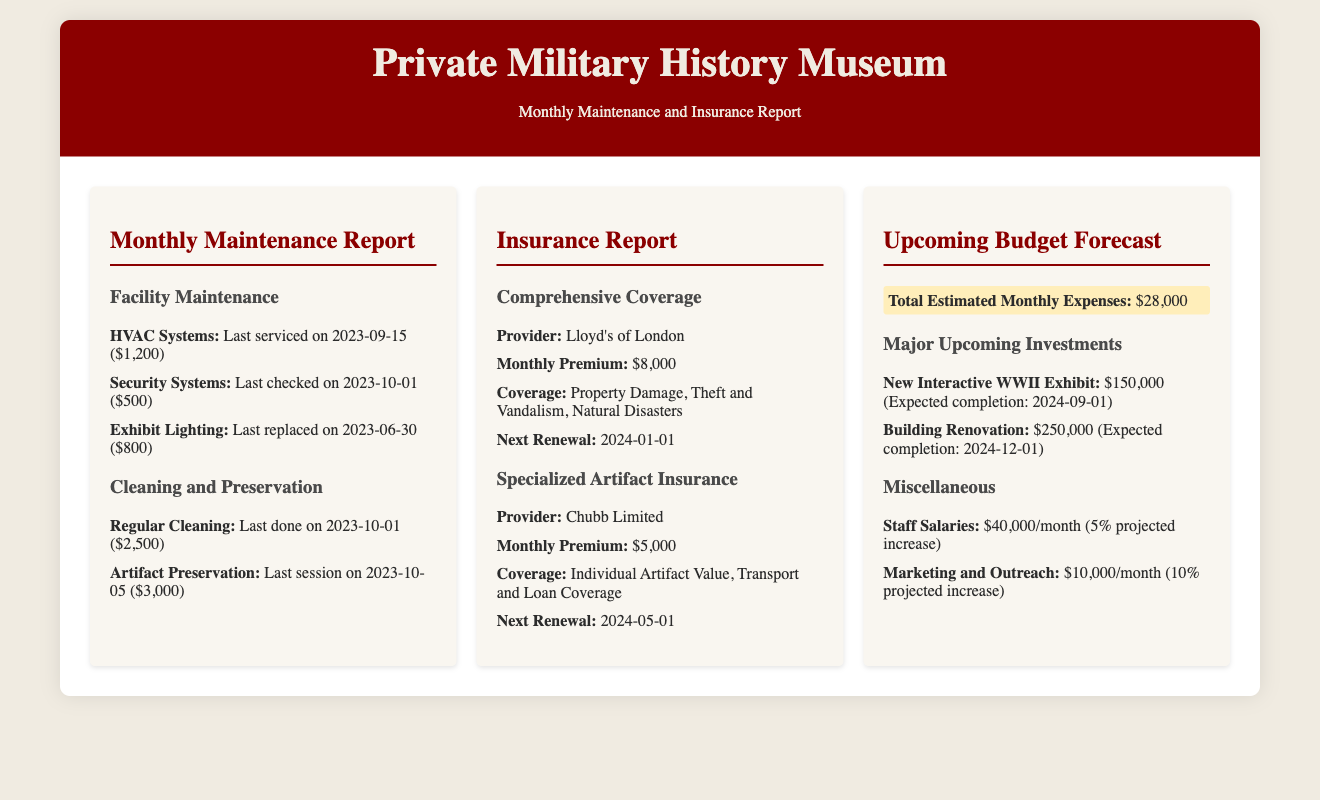what is the last service date for the HVAC systems? The HVAC systems were last serviced on September 15, 2023.
Answer: September 15, 2023 how much was spent on regular cleaning in October? The regular cleaning was last done on October 1, costing $2,500.
Answer: $2,500 what is the next renewal date for the comprehensive insurance coverage? The next renewal date for the comprehensive insurance coverage is January 1, 2024.
Answer: January 1, 2024 what is the total estimated monthly expenses? The total estimated monthly expenses listed in the document is $28,000.
Answer: $28,000 which providers are mentioned for insurance? Two insurance providers are named: Lloyd's of London and Chubb Limited.
Answer: Lloyd's of London, Chubb Limited how much will the new interactive WWII exhibit cost? The cost of the new interactive WWII exhibit is projected to be $150,000.
Answer: $150,000 what percentage increase is projected for staff salaries? The document states a 5% projected increase for staff salaries.
Answer: 5% what is the maintenance cost for the security systems? The total maintenance cost for the security systems was $500.
Answer: $500 what is the expected completion date for the building renovation? The expected completion date for the building renovation is December 1, 2024.
Answer: December 1, 2024 